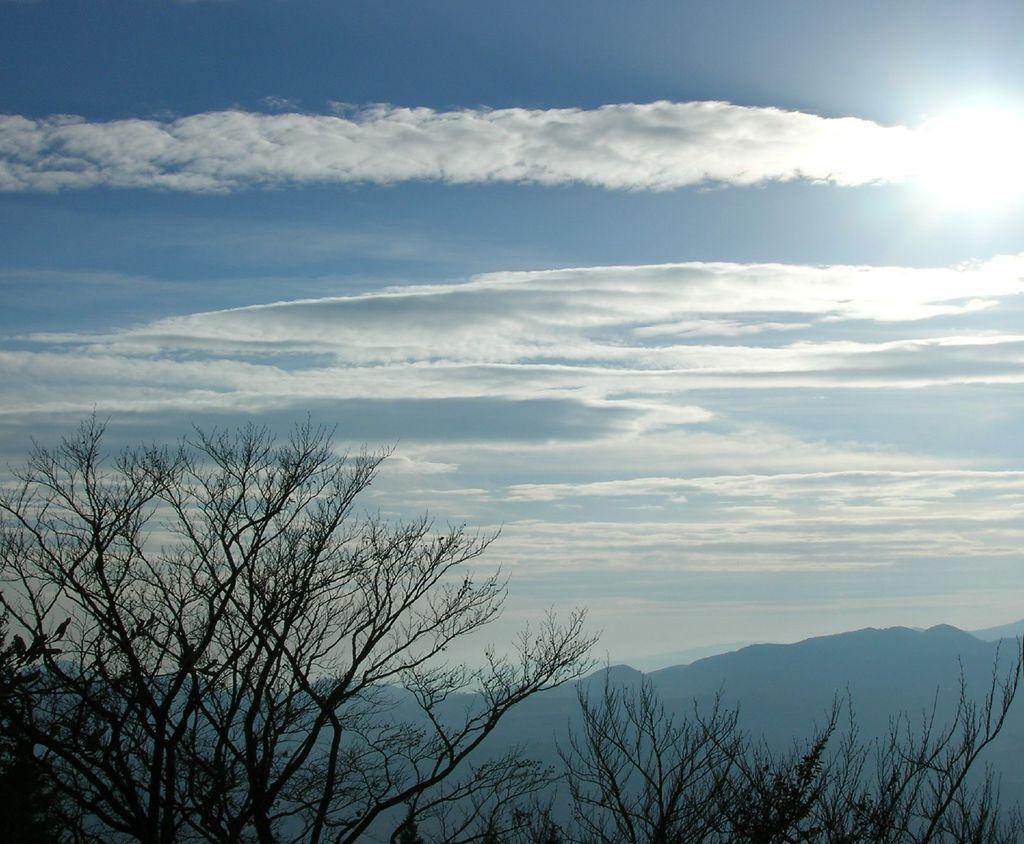What type of vegetation is at the bottom of the image? There are trees at the bottom of the image. What is visible at the top of the image? The sky is visible at the top of the image. What can be seen in the sky? Clouds are present in the sky. What type of geographical feature is in the background of the image? There are mountains in the background of the image. Where are the books located in the image? There are no books present in the image. What type of attack is happening in the image? There is no attack depicted in the image; it features trees, sky, clouds, and mountains. 